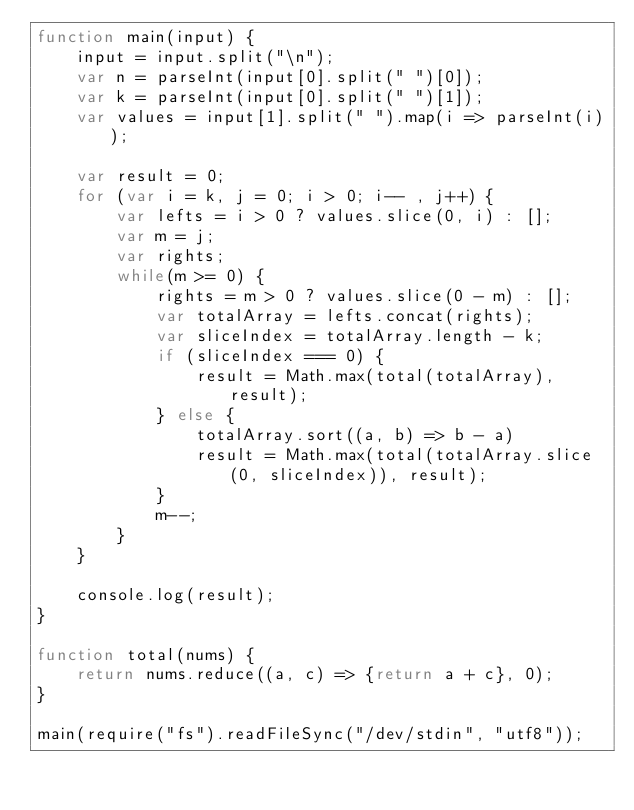Convert code to text. <code><loc_0><loc_0><loc_500><loc_500><_JavaScript_>function main(input) {
    input = input.split("\n");
    var n = parseInt(input[0].split(" ")[0]);
    var k = parseInt(input[0].split(" ")[1]);
    var values = input[1].split(" ").map(i => parseInt(i));

    var result = 0;
    for (var i = k, j = 0; i > 0; i-- , j++) {
        var lefts = i > 0 ? values.slice(0, i) : [];
        var m = j;
        var rights;
        while(m >= 0) {
            rights = m > 0 ? values.slice(0 - m) : [];
            var totalArray = lefts.concat(rights);
            var sliceIndex = totalArray.length - k;
            if (sliceIndex === 0) {
                result = Math.max(total(totalArray), result);
            } else {
                totalArray.sort((a, b) => b - a)
                result = Math.max(total(totalArray.slice(0, sliceIndex)), result);
            }
            m--;
        }
    }

    console.log(result);
}

function total(nums) {
    return nums.reduce((a, c) => {return a + c}, 0);
}

main(require("fs").readFileSync("/dev/stdin", "utf8"));</code> 